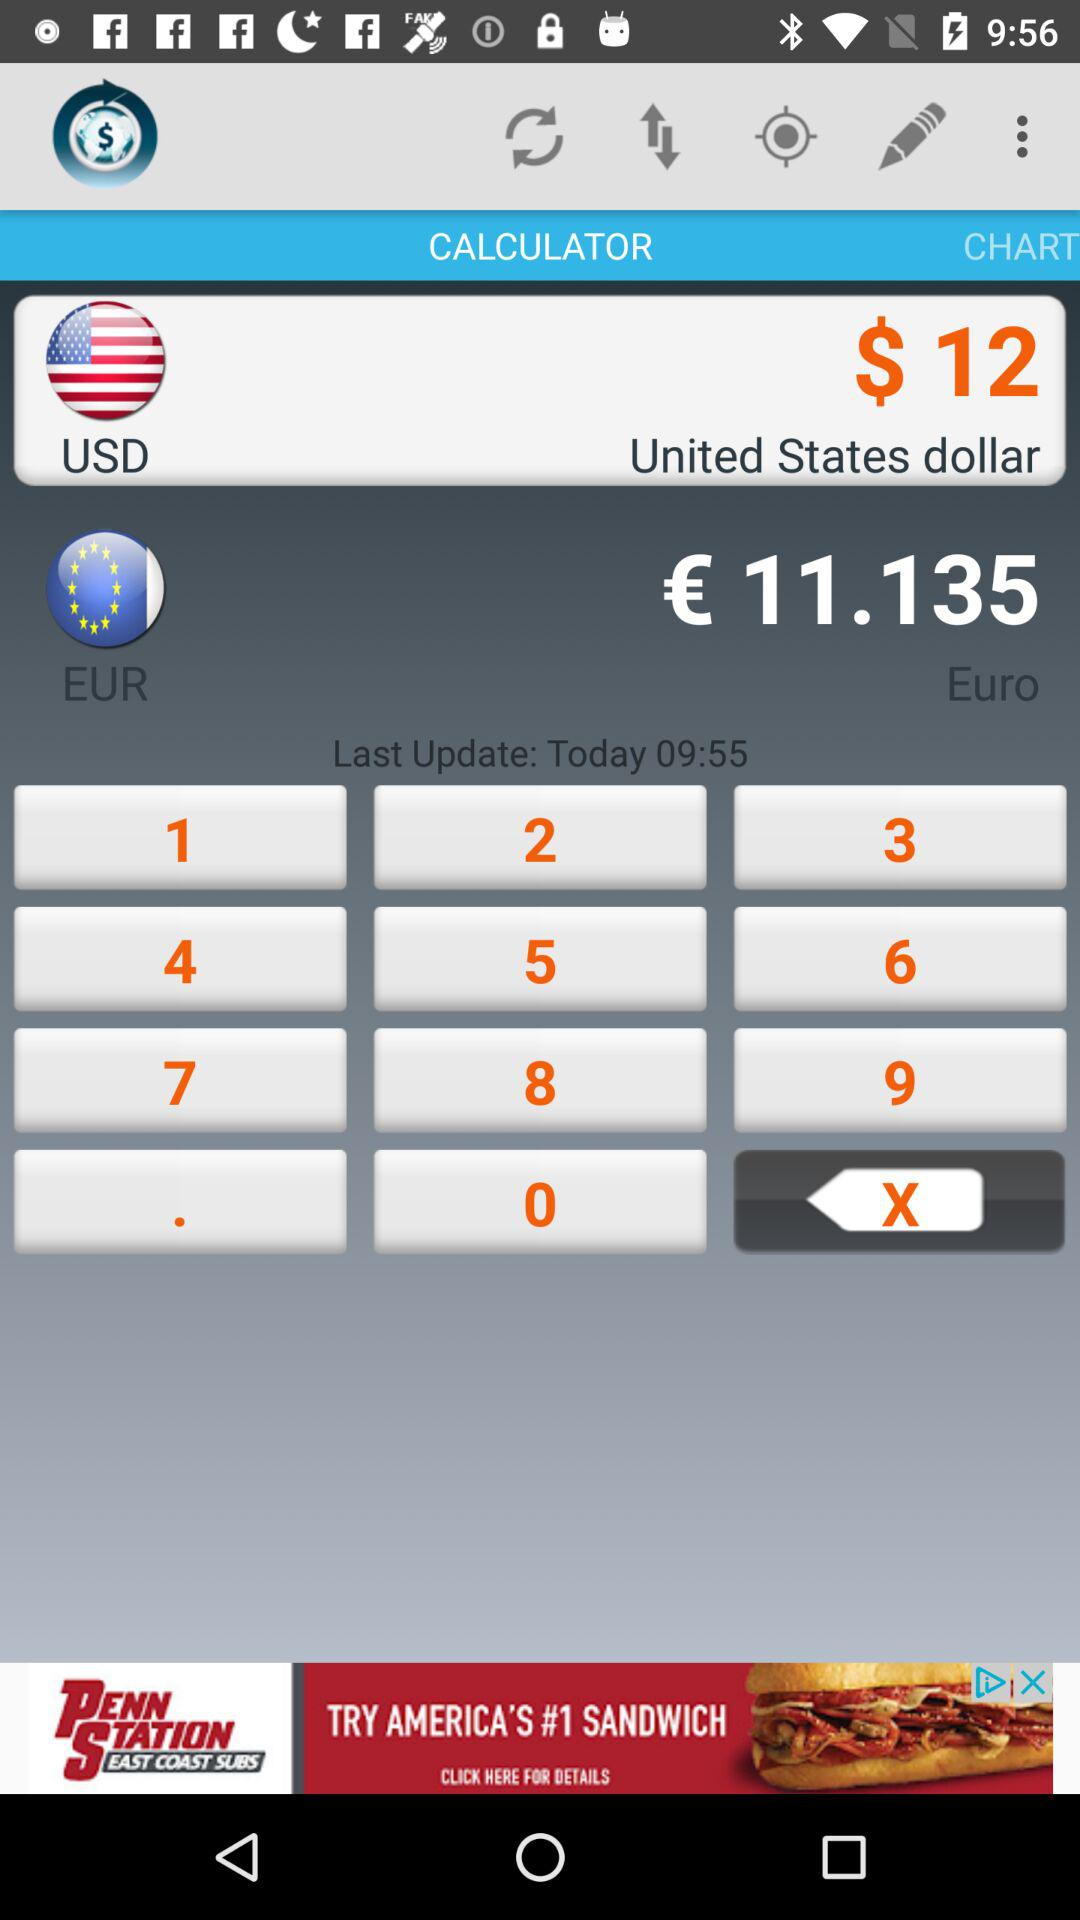What is the value of $12 in European currency? The value of $12 in European currency is €11.135. 